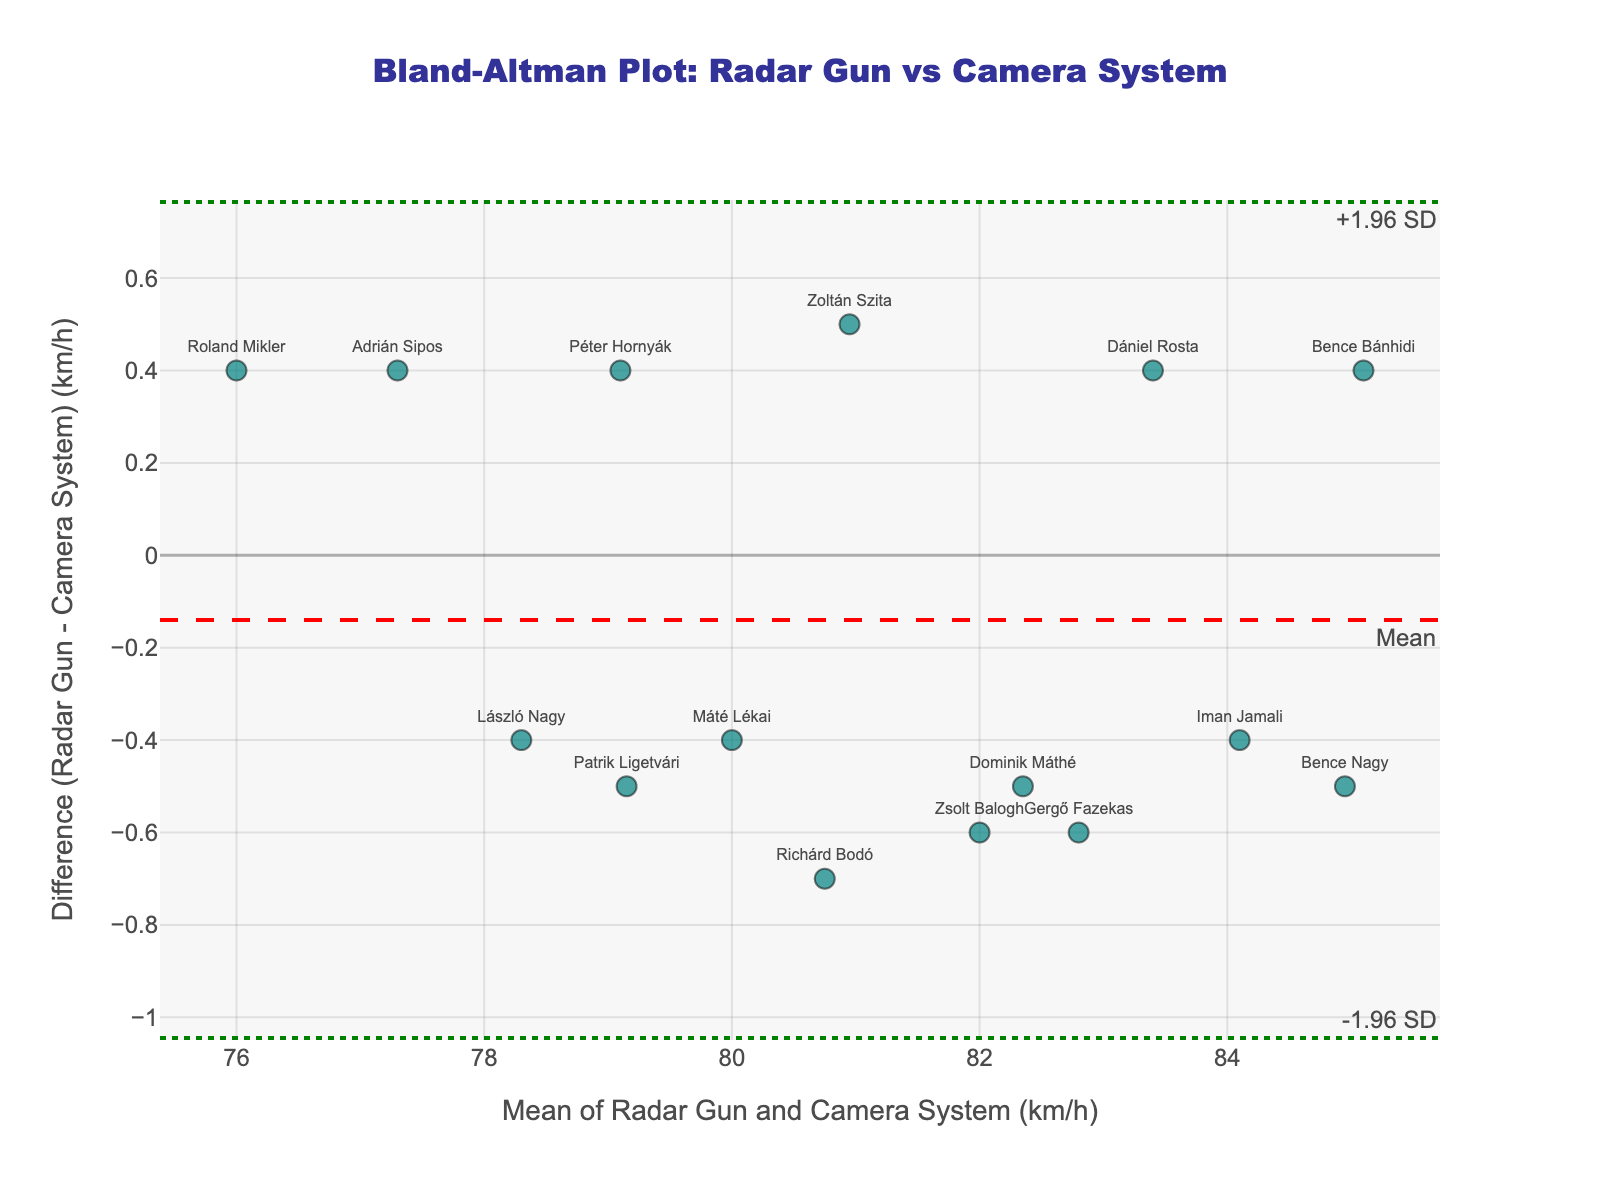What is the title of the figure? The title of the figure is located at the top of the plot. It is displayed in a distinct format and explains the purpose of the plot using natural language.
Answer: Bland-Altman Plot: Radar Gun vs Camera System What do the x-axis and y-axis represent in the plot? The x-axis title states "Mean of Radar Gun and Camera System (km/h)" indicating it represents the mean velocities measured by both methods. The y-axis title states "Difference (Radar Gun - Camera System) (km/h)" indicating it represents the difference between the velocities measured by the radar gun and the camera system.
Answer: The x-axis represents the mean velocities, and the y-axis represents the differences in velocities How many data points are plotted in the figure? Count the individual markers denoting each player's data point plotted on the graph. Each player corresponds to a marker with a label. The dataset includes names that match to their velocities measured by both methods.
Answer: 15 What are the values for the upper and lower limits of agreement? Locate the green dotted lines which represent the ±1.96 standard deviation (SD) lines around the mean difference. These lines are annotated with "+1.96 SD" and "-1.96 SD".
Answer: Upper: 1.492, Lower: -1.652 Which players have the largest positive and negative differences? Examine the scatter points to identify the player names closest to the highest and lowest y-axis values. The player names are annotated near each marker.
Answer: Positive: Richárd Bodó, Negative: Roland Mikler What is the average (mean) difference between the radar gun and camera system velocities? The mean difference is represented as a red dashed horizontal line on the plot and is labeled "Mean".
Answer: -0.08 km/h Which player's velocity measurements are closest in agreement? Find the scatter point closest to the y-axis value of 0 because this indicates the smallest difference between radar gun and camera system measurements.
Answer: Patrik Ligetvári Are there any players whose differences fall outside the limits of agreement? To determine this, check whether any player's data points are plotted outside the green dotted lines (+1.96 SD and -1.96 SD).
Answer: No What does a positive difference indicate in this plot? In this plot, a positive difference means that the radar gun measurement is higher than the camera system measurement by the value indicated on the y-axis.
Answer: Radar gun measures higher than the camera system Is the variability (spread) of the differences consistent across the range of mean velocities? Observe the spread of data points (scatter) along the x-axis (mean velocities). If the spread is consistent, the differences do not expand or contract across the range of means.
Answer: Yes, relatively consistent 